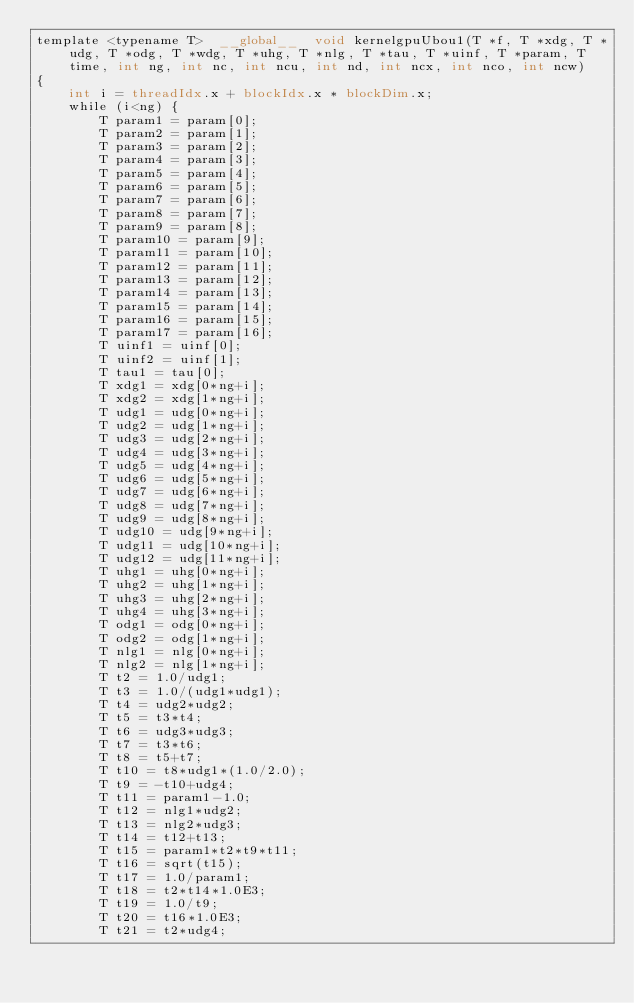<code> <loc_0><loc_0><loc_500><loc_500><_Cuda_>template <typename T>  __global__  void kernelgpuUbou1(T *f, T *xdg, T *udg, T *odg, T *wdg, T *uhg, T *nlg, T *tau, T *uinf, T *param, T time, int ng, int nc, int ncu, int nd, int ncx, int nco, int ncw)
{
	int i = threadIdx.x + blockIdx.x * blockDim.x;
	while (i<ng) {
		T param1 = param[0];
		T param2 = param[1];
		T param3 = param[2];
		T param4 = param[3];
		T param5 = param[4];
		T param6 = param[5];
		T param7 = param[6];
		T param8 = param[7];
		T param9 = param[8];
		T param10 = param[9];
		T param11 = param[10];
		T param12 = param[11];
		T param13 = param[12];
		T param14 = param[13];
		T param15 = param[14];
		T param16 = param[15];
		T param17 = param[16];
		T uinf1 = uinf[0];
		T uinf2 = uinf[1];
		T tau1 = tau[0];
		T xdg1 = xdg[0*ng+i];
		T xdg2 = xdg[1*ng+i];
		T udg1 = udg[0*ng+i];
		T udg2 = udg[1*ng+i];
		T udg3 = udg[2*ng+i];
		T udg4 = udg[3*ng+i];
		T udg5 = udg[4*ng+i];
		T udg6 = udg[5*ng+i];
		T udg7 = udg[6*ng+i];
		T udg8 = udg[7*ng+i];
		T udg9 = udg[8*ng+i];
		T udg10 = udg[9*ng+i];
		T udg11 = udg[10*ng+i];
		T udg12 = udg[11*ng+i];
		T uhg1 = uhg[0*ng+i];
		T uhg2 = uhg[1*ng+i];
		T uhg3 = uhg[2*ng+i];
		T uhg4 = uhg[3*ng+i];
		T odg1 = odg[0*ng+i];
		T odg2 = odg[1*ng+i];
		T nlg1 = nlg[0*ng+i];
		T nlg2 = nlg[1*ng+i];
		T t2 = 1.0/udg1;
		T t3 = 1.0/(udg1*udg1);
		T t4 = udg2*udg2;
		T t5 = t3*t4;
		T t6 = udg3*udg3;
		T t7 = t3*t6;
		T t8 = t5+t7;
		T t10 = t8*udg1*(1.0/2.0);
		T t9 = -t10+udg4;
		T t11 = param1-1.0;
		T t12 = nlg1*udg2;
		T t13 = nlg2*udg3;
		T t14 = t12+t13;
		T t15 = param1*t2*t9*t11;
		T t16 = sqrt(t15);
		T t17 = 1.0/param1;
		T t18 = t2*t14*1.0E3;
		T t19 = 1.0/t9;
		T t20 = t16*1.0E3;
		T t21 = t2*udg4;</code> 